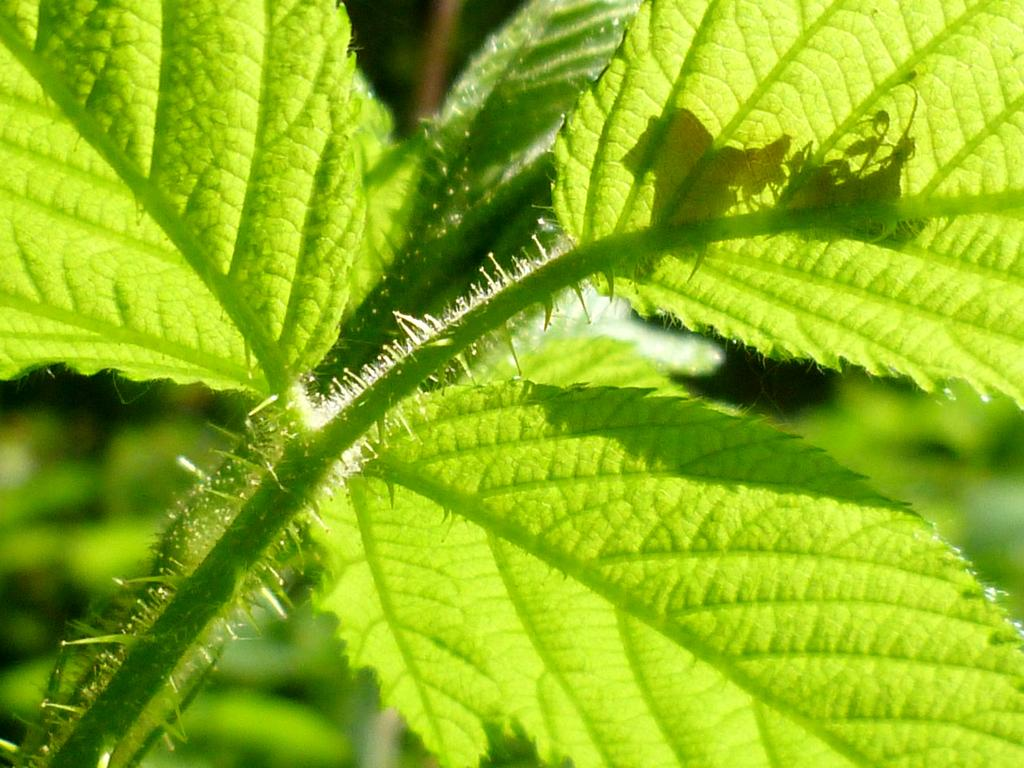What type of vegetation can be seen in the image? There are leaves in the image. Where are the leaves located in relation to the steam? The leaves are in front of a steam in the image. How would you describe the background of the image? The background of the image is blurred. What type of knot is being tied in the image? There is no knot present in the image; it features leaves in front of a steam with a blurred background. 